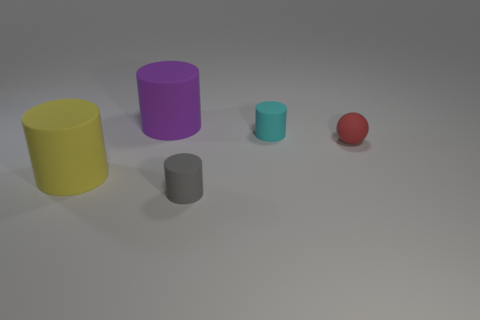How would you describe the arrangement of the objects? The objects are arranged with ample spacing on what looks like a neutral background. From left to right, they are ordered by size with the largest cylinder first, followed by the smaller ones, and the tiny ball at the end, creating a descending line in terms of size. 